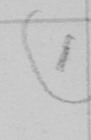Can you tell me what this handwritten text says? ( 1 